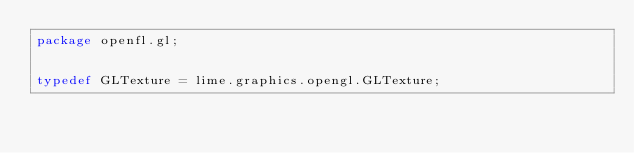<code> <loc_0><loc_0><loc_500><loc_500><_Haxe_>package openfl.gl;


typedef GLTexture = lime.graphics.opengl.GLTexture;</code> 